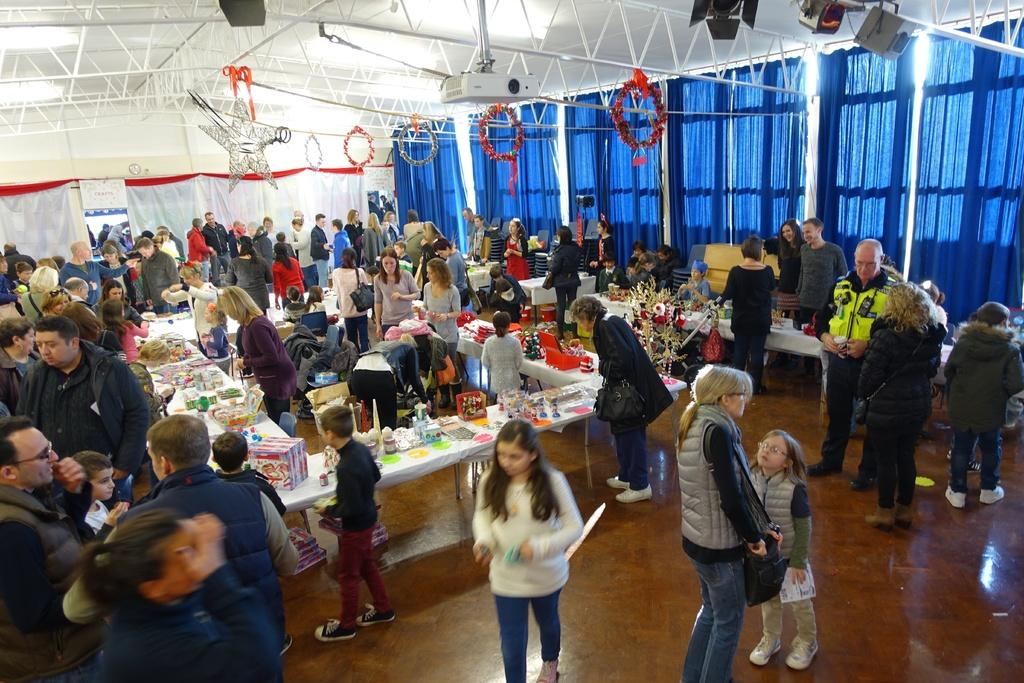What type of establishment is shown in the image? The image depicts a store. What are the people in the image doing? There is a group of people walking and observing in the image. Can you describe any specific features of the store? There is a projector at the top of the image. What type of worm can be seen crawling on the projector in the image? There are no worms present in the image, and therefore no such activity can be observed. 